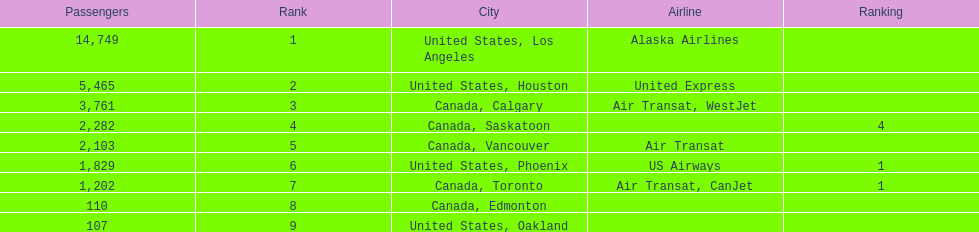Can you give me this table as a dict? {'header': ['Passengers', 'Rank', 'City', 'Airline', 'Ranking'], 'rows': [['14,749', '1', 'United States, Los Angeles', 'Alaska Airlines', ''], ['5,465', '2', 'United States, Houston', 'United Express', ''], ['3,761', '3', 'Canada, Calgary', 'Air Transat, WestJet', ''], ['2,282', '4', 'Canada, Saskatoon', '', '4'], ['2,103', '5', 'Canada, Vancouver', 'Air Transat', ''], ['1,829', '6', 'United States, Phoenix', 'US Airways', '1'], ['1,202', '7', 'Canada, Toronto', 'Air Transat, CanJet', '1'], ['110', '8', 'Canada, Edmonton', '', ''], ['107', '9', 'United States, Oakland', '', '']]} What is the average number of passengers in the united states? 5537.5. 